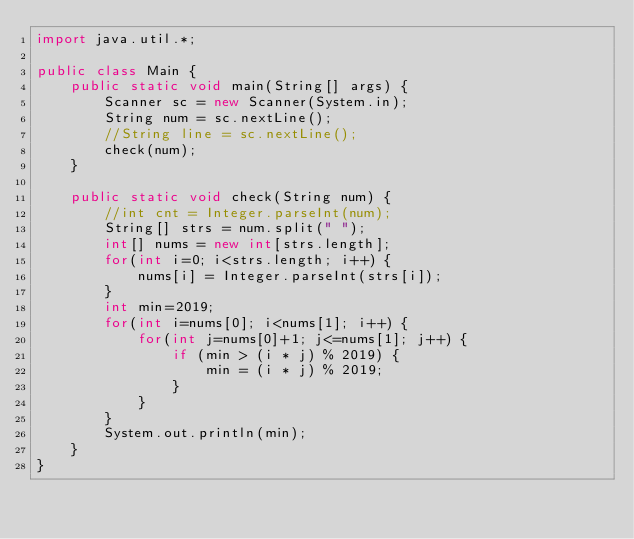Convert code to text. <code><loc_0><loc_0><loc_500><loc_500><_Java_>import java.util.*;

public class Main {
    public static void main(String[] args) {
        Scanner sc = new Scanner(System.in);
        String num = sc.nextLine();
        //String line = sc.nextLine();
        check(num);
    }

    public static void check(String num) {
        //int cnt = Integer.parseInt(num);
        String[] strs = num.split(" ");
        int[] nums = new int[strs.length];
        for(int i=0; i<strs.length; i++) {
            nums[i] = Integer.parseInt(strs[i]);
        }
        int min=2019;
        for(int i=nums[0]; i<nums[1]; i++) {
            for(int j=nums[0]+1; j<=nums[1]; j++) {
                if (min > (i * j) % 2019) {
                    min = (i * j) % 2019;
                }
            }
        }
        System.out.println(min);
    }
}</code> 